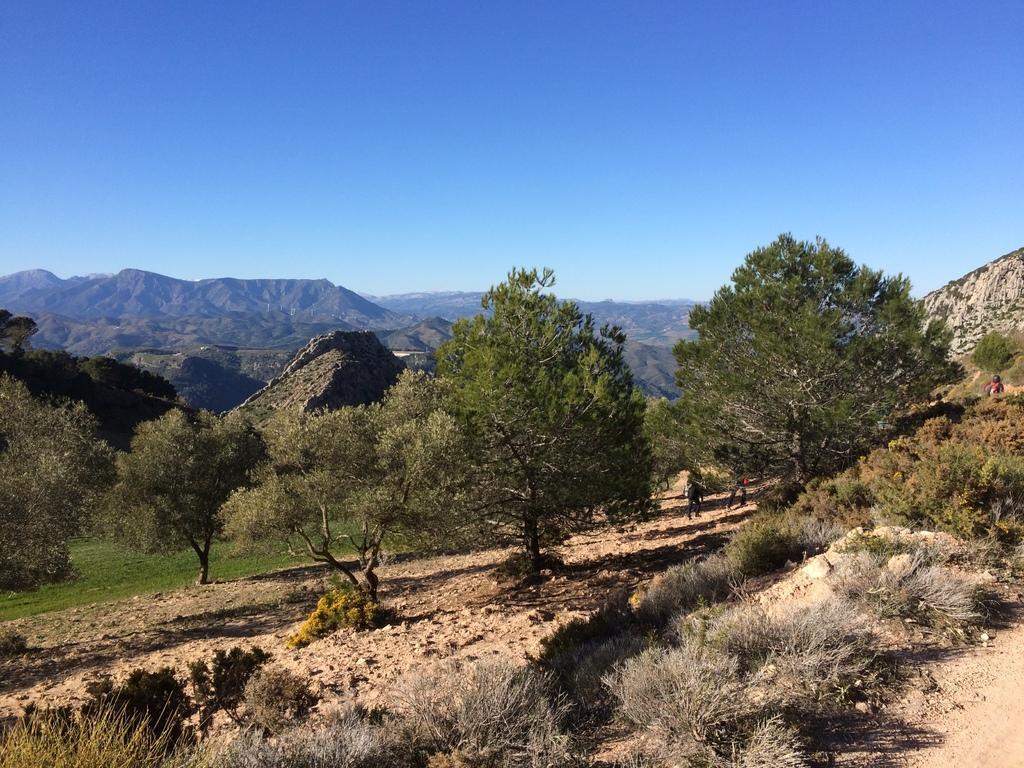Can you describe this image briefly? In this picture there are mountains and trees and there are three people walking behind the tree. At the top there is sky. At the bottom there are plants and there's grass on the ground. 